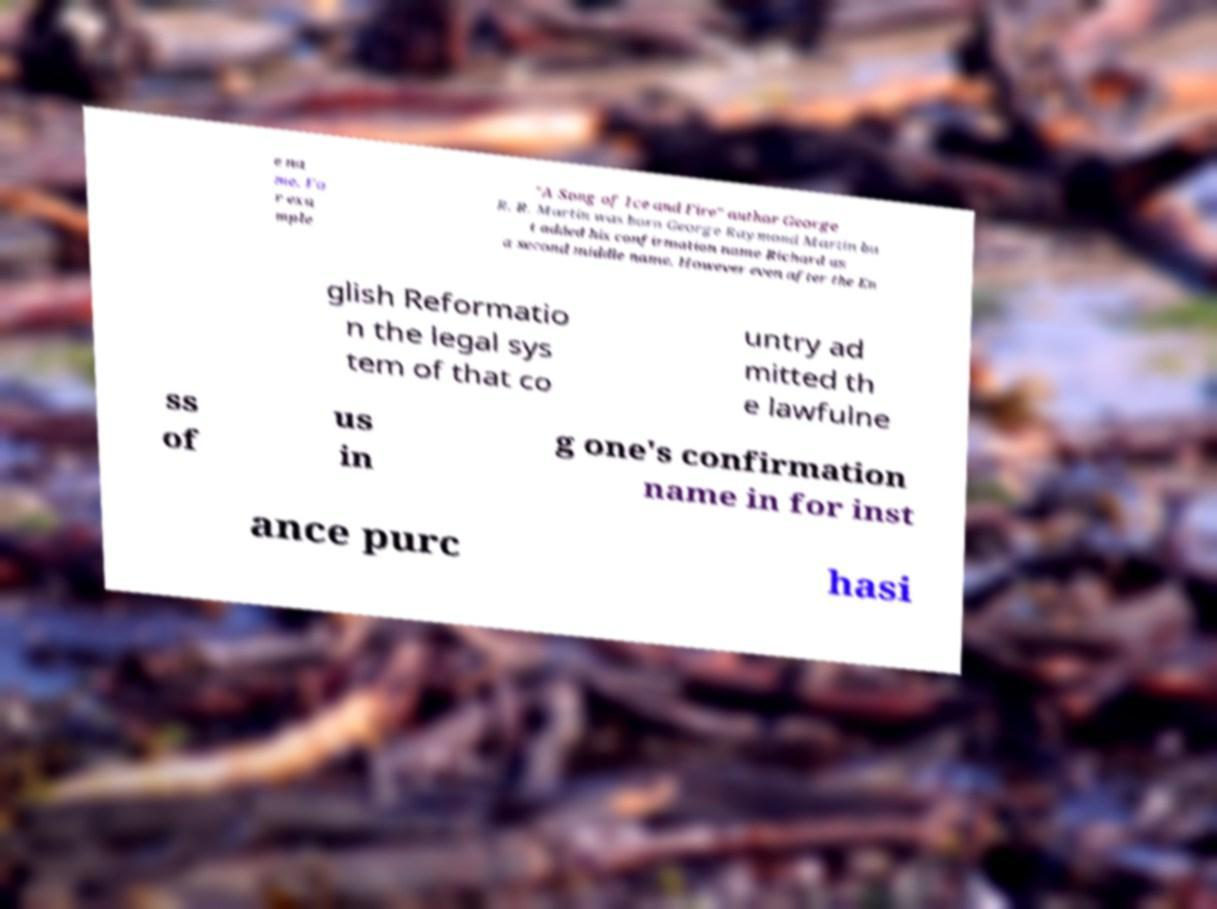For documentation purposes, I need the text within this image transcribed. Could you provide that? e na me. Fo r exa mple "A Song of Ice and Fire" author George R. R. Martin was born George Raymond Martin bu t added his confirmation name Richard as a second middle name. However even after the En glish Reformatio n the legal sys tem of that co untry ad mitted th e lawfulne ss of us in g one's confirmation name in for inst ance purc hasi 